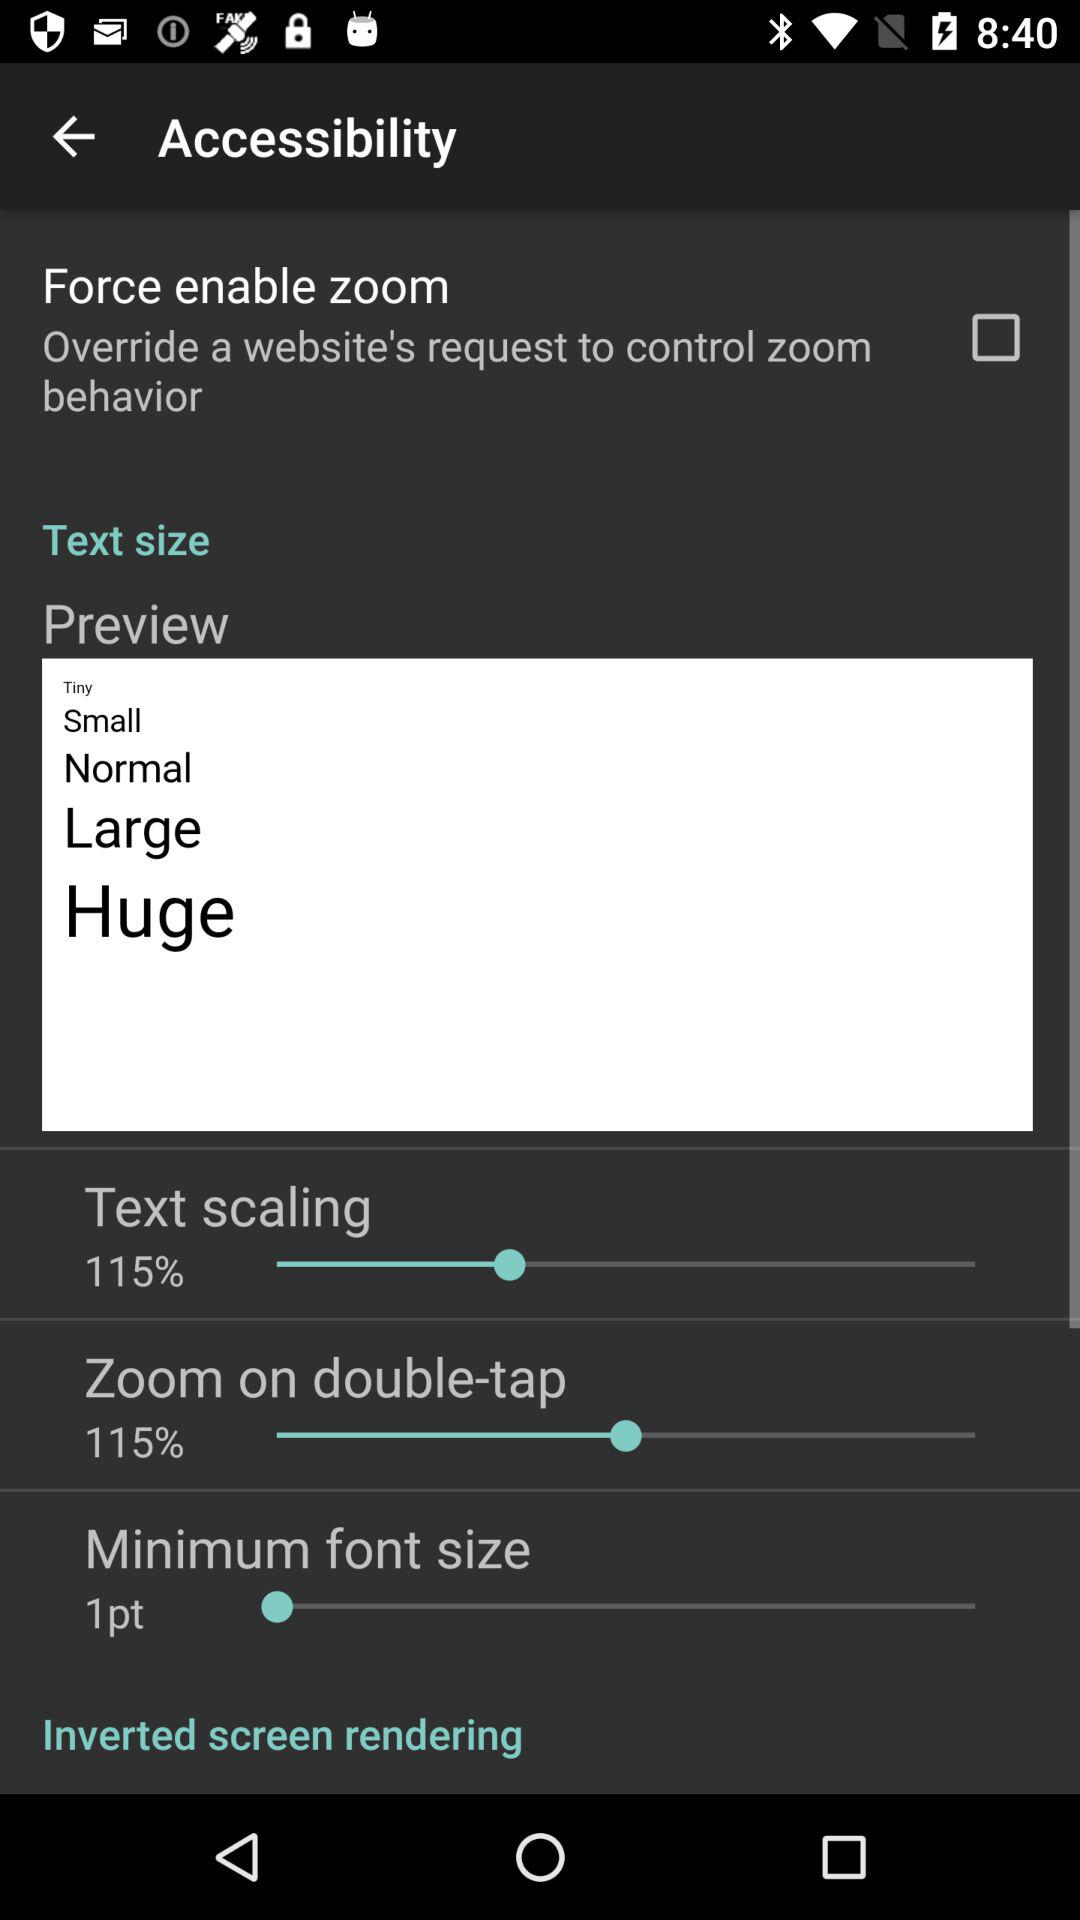What is the status of the minimum font size? The status of the "minimum font size" is 1 point. 